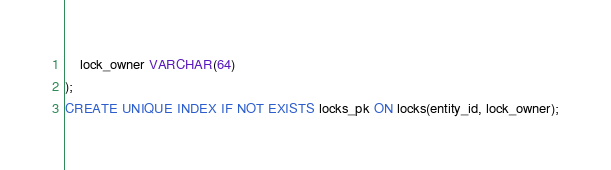<code> <loc_0><loc_0><loc_500><loc_500><_SQL_>    lock_owner VARCHAR(64)
);
CREATE UNIQUE INDEX IF NOT EXISTS locks_pk ON locks(entity_id, lock_owner);
</code> 